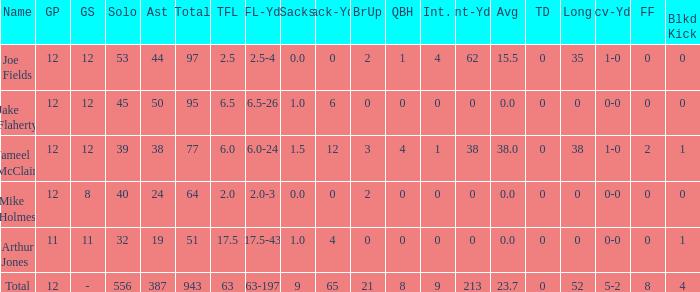What is the total brup for the team? 21.0. 